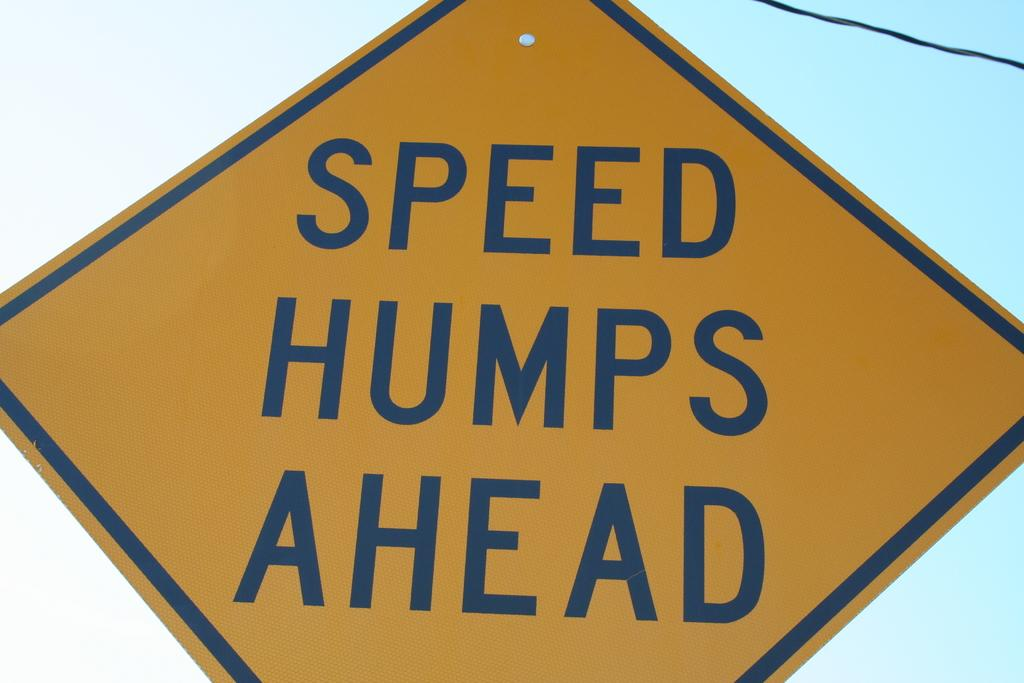<image>
Present a compact description of the photo's key features. A road sign warning of speed bumps ahead. 